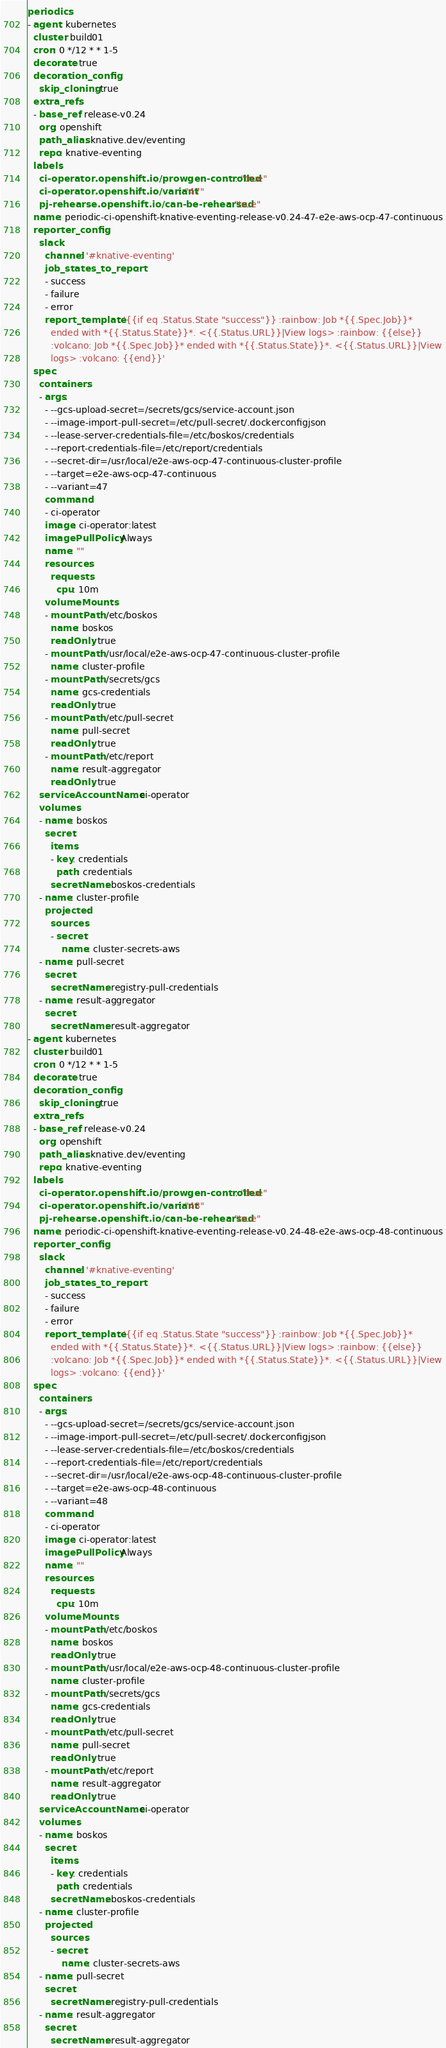<code> <loc_0><loc_0><loc_500><loc_500><_YAML_>periodics:
- agent: kubernetes
  cluster: build01
  cron: 0 */12 * * 1-5
  decorate: true
  decoration_config:
    skip_cloning: true
  extra_refs:
  - base_ref: release-v0.24
    org: openshift
    path_alias: knative.dev/eventing
    repo: knative-eventing
  labels:
    ci-operator.openshift.io/prowgen-controlled: "true"
    ci-operator.openshift.io/variant: "47"
    pj-rehearse.openshift.io/can-be-rehearsed: "true"
  name: periodic-ci-openshift-knative-eventing-release-v0.24-47-e2e-aws-ocp-47-continuous
  reporter_config:
    slack:
      channel: '#knative-eventing'
      job_states_to_report:
      - success
      - failure
      - error
      report_template: '{{if eq .Status.State "success"}} :rainbow: Job *{{.Spec.Job}}*
        ended with *{{.Status.State}}*. <{{.Status.URL}}|View logs> :rainbow: {{else}}
        :volcano: Job *{{.Spec.Job}}* ended with *{{.Status.State}}*. <{{.Status.URL}}|View
        logs> :volcano: {{end}}'
  spec:
    containers:
    - args:
      - --gcs-upload-secret=/secrets/gcs/service-account.json
      - --image-import-pull-secret=/etc/pull-secret/.dockerconfigjson
      - --lease-server-credentials-file=/etc/boskos/credentials
      - --report-credentials-file=/etc/report/credentials
      - --secret-dir=/usr/local/e2e-aws-ocp-47-continuous-cluster-profile
      - --target=e2e-aws-ocp-47-continuous
      - --variant=47
      command:
      - ci-operator
      image: ci-operator:latest
      imagePullPolicy: Always
      name: ""
      resources:
        requests:
          cpu: 10m
      volumeMounts:
      - mountPath: /etc/boskos
        name: boskos
        readOnly: true
      - mountPath: /usr/local/e2e-aws-ocp-47-continuous-cluster-profile
        name: cluster-profile
      - mountPath: /secrets/gcs
        name: gcs-credentials
        readOnly: true
      - mountPath: /etc/pull-secret
        name: pull-secret
        readOnly: true
      - mountPath: /etc/report
        name: result-aggregator
        readOnly: true
    serviceAccountName: ci-operator
    volumes:
    - name: boskos
      secret:
        items:
        - key: credentials
          path: credentials
        secretName: boskos-credentials
    - name: cluster-profile
      projected:
        sources:
        - secret:
            name: cluster-secrets-aws
    - name: pull-secret
      secret:
        secretName: registry-pull-credentials
    - name: result-aggregator
      secret:
        secretName: result-aggregator
- agent: kubernetes
  cluster: build01
  cron: 0 */12 * * 1-5
  decorate: true
  decoration_config:
    skip_cloning: true
  extra_refs:
  - base_ref: release-v0.24
    org: openshift
    path_alias: knative.dev/eventing
    repo: knative-eventing
  labels:
    ci-operator.openshift.io/prowgen-controlled: "true"
    ci-operator.openshift.io/variant: "48"
    pj-rehearse.openshift.io/can-be-rehearsed: "true"
  name: periodic-ci-openshift-knative-eventing-release-v0.24-48-e2e-aws-ocp-48-continuous
  reporter_config:
    slack:
      channel: '#knative-eventing'
      job_states_to_report:
      - success
      - failure
      - error
      report_template: '{{if eq .Status.State "success"}} :rainbow: Job *{{.Spec.Job}}*
        ended with *{{.Status.State}}*. <{{.Status.URL}}|View logs> :rainbow: {{else}}
        :volcano: Job *{{.Spec.Job}}* ended with *{{.Status.State}}*. <{{.Status.URL}}|View
        logs> :volcano: {{end}}'
  spec:
    containers:
    - args:
      - --gcs-upload-secret=/secrets/gcs/service-account.json
      - --image-import-pull-secret=/etc/pull-secret/.dockerconfigjson
      - --lease-server-credentials-file=/etc/boskos/credentials
      - --report-credentials-file=/etc/report/credentials
      - --secret-dir=/usr/local/e2e-aws-ocp-48-continuous-cluster-profile
      - --target=e2e-aws-ocp-48-continuous
      - --variant=48
      command:
      - ci-operator
      image: ci-operator:latest
      imagePullPolicy: Always
      name: ""
      resources:
        requests:
          cpu: 10m
      volumeMounts:
      - mountPath: /etc/boskos
        name: boskos
        readOnly: true
      - mountPath: /usr/local/e2e-aws-ocp-48-continuous-cluster-profile
        name: cluster-profile
      - mountPath: /secrets/gcs
        name: gcs-credentials
        readOnly: true
      - mountPath: /etc/pull-secret
        name: pull-secret
        readOnly: true
      - mountPath: /etc/report
        name: result-aggregator
        readOnly: true
    serviceAccountName: ci-operator
    volumes:
    - name: boskos
      secret:
        items:
        - key: credentials
          path: credentials
        secretName: boskos-credentials
    - name: cluster-profile
      projected:
        sources:
        - secret:
            name: cluster-secrets-aws
    - name: pull-secret
      secret:
        secretName: registry-pull-credentials
    - name: result-aggregator
      secret:
        secretName: result-aggregator
</code> 